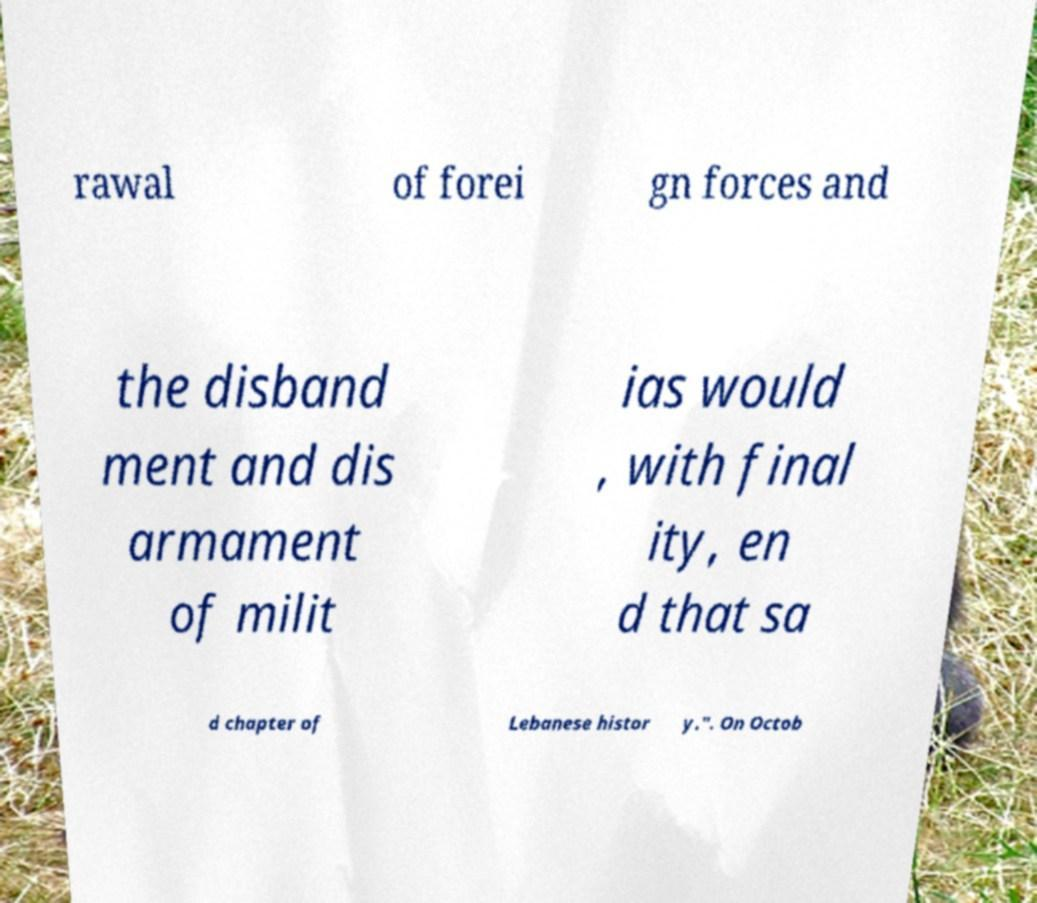I need the written content from this picture converted into text. Can you do that? rawal of forei gn forces and the disband ment and dis armament of milit ias would , with final ity, en d that sa d chapter of Lebanese histor y.". On Octob 